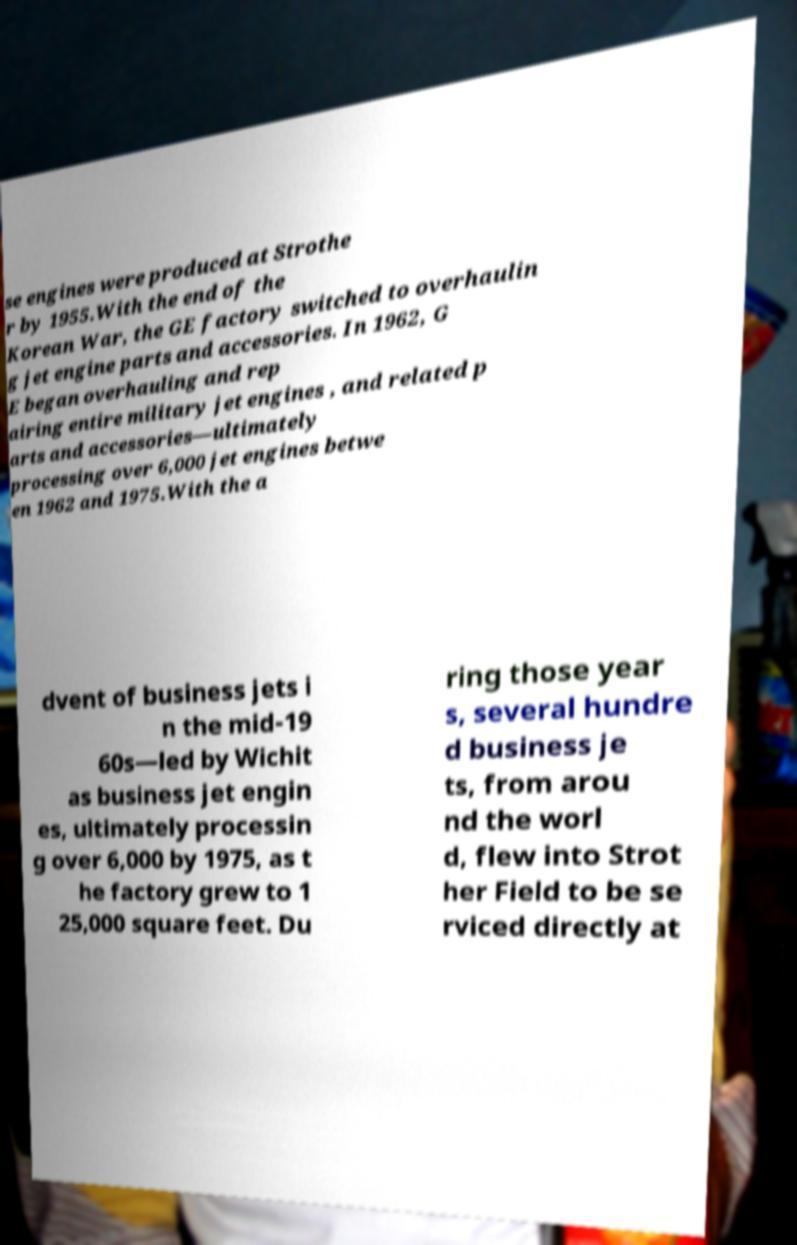Please read and relay the text visible in this image. What does it say? se engines were produced at Strothe r by 1955.With the end of the Korean War, the GE factory switched to overhaulin g jet engine parts and accessories. In 1962, G E began overhauling and rep airing entire military jet engines , and related p arts and accessories—ultimately processing over 6,000 jet engines betwe en 1962 and 1975.With the a dvent of business jets i n the mid-19 60s—led by Wichit as business jet engin es, ultimately processin g over 6,000 by 1975, as t he factory grew to 1 25,000 square feet. Du ring those year s, several hundre d business je ts, from arou nd the worl d, flew into Strot her Field to be se rviced directly at 